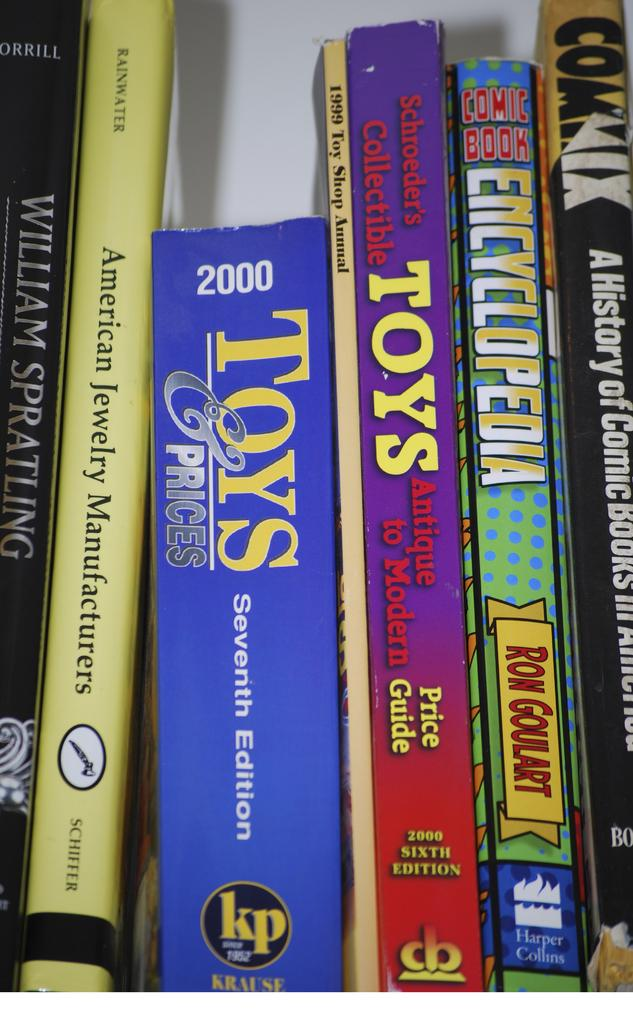<image>
Provide a brief description of the given image. Books about toys, jewelry, encyclopedia, and history lined up together 